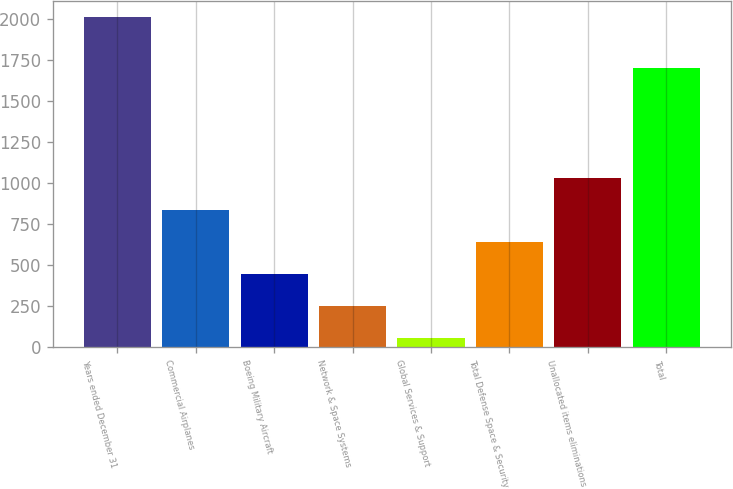Convert chart. <chart><loc_0><loc_0><loc_500><loc_500><bar_chart><fcel>Years ended December 31<fcel>Commercial Airplanes<fcel>Boeing Military Aircraft<fcel>Network & Space Systems<fcel>Global Services & Support<fcel>Total Defense Space & Security<fcel>Unallocated items eliminations<fcel>Total<nl><fcel>2012<fcel>839<fcel>448<fcel>252.5<fcel>57<fcel>643.5<fcel>1034.5<fcel>1703<nl></chart> 